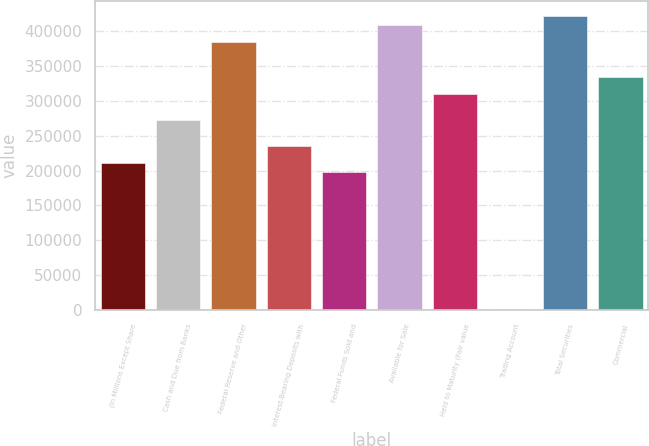Convert chart. <chart><loc_0><loc_0><loc_500><loc_500><bar_chart><fcel>(In Millions Except Share<fcel>Cash and Due from Banks<fcel>Federal Reserve and Other<fcel>Interest-Bearing Deposits with<fcel>Federal Funds Sold and<fcel>Available for Sale<fcel>Held to Maturity (Fair value<fcel>Trading Account<fcel>Total Securities<fcel>Commercial<nl><fcel>210676<fcel>272639<fcel>384173<fcel>235461<fcel>198283<fcel>408958<fcel>309817<fcel>0.3<fcel>421351<fcel>334602<nl></chart> 